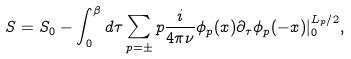<formula> <loc_0><loc_0><loc_500><loc_500>S = S _ { 0 } - \int _ { 0 } ^ { \beta } d \tau \sum _ { p = \pm } p \frac { i } { 4 \pi \nu } \phi _ { p } ( x ) \partial _ { \tau } \phi _ { p } ( - x ) | _ { 0 } ^ { L _ { p } / 2 } ,</formula> 